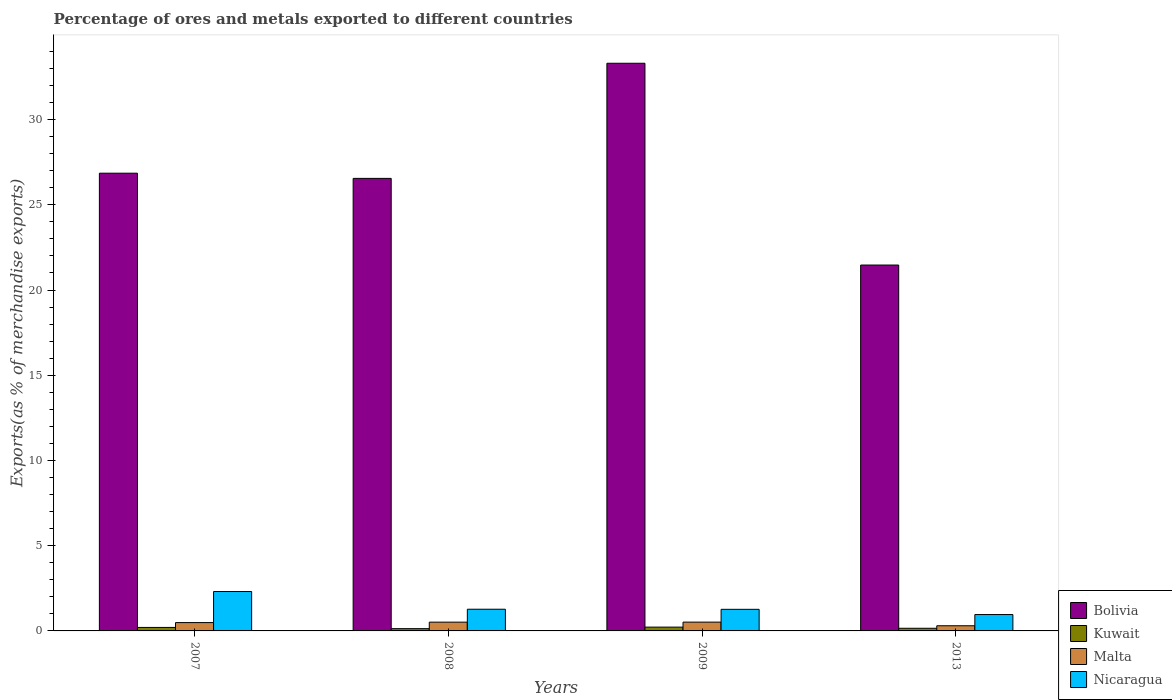How many groups of bars are there?
Your response must be concise. 4. How many bars are there on the 2nd tick from the left?
Provide a succinct answer. 4. How many bars are there on the 4th tick from the right?
Ensure brevity in your answer.  4. In how many cases, is the number of bars for a given year not equal to the number of legend labels?
Provide a short and direct response. 0. What is the percentage of exports to different countries in Kuwait in 2013?
Your answer should be very brief. 0.16. Across all years, what is the maximum percentage of exports to different countries in Bolivia?
Provide a succinct answer. 33.3. Across all years, what is the minimum percentage of exports to different countries in Kuwait?
Provide a short and direct response. 0.13. What is the total percentage of exports to different countries in Nicaragua in the graph?
Give a very brief answer. 5.81. What is the difference between the percentage of exports to different countries in Kuwait in 2007 and that in 2009?
Your answer should be compact. -0.02. What is the difference between the percentage of exports to different countries in Kuwait in 2007 and the percentage of exports to different countries in Malta in 2013?
Your answer should be very brief. -0.1. What is the average percentage of exports to different countries in Kuwait per year?
Offer a terse response. 0.18. In the year 2008, what is the difference between the percentage of exports to different countries in Kuwait and percentage of exports to different countries in Bolivia?
Provide a succinct answer. -26.42. What is the ratio of the percentage of exports to different countries in Bolivia in 2007 to that in 2009?
Offer a terse response. 0.81. Is the percentage of exports to different countries in Nicaragua in 2007 less than that in 2009?
Your answer should be very brief. No. What is the difference between the highest and the second highest percentage of exports to different countries in Malta?
Provide a succinct answer. 0. What is the difference between the highest and the lowest percentage of exports to different countries in Nicaragua?
Provide a short and direct response. 1.35. Is it the case that in every year, the sum of the percentage of exports to different countries in Kuwait and percentage of exports to different countries in Malta is greater than the sum of percentage of exports to different countries in Nicaragua and percentage of exports to different countries in Bolivia?
Provide a succinct answer. No. What does the 1st bar from the left in 2007 represents?
Your answer should be compact. Bolivia. Is it the case that in every year, the sum of the percentage of exports to different countries in Bolivia and percentage of exports to different countries in Nicaragua is greater than the percentage of exports to different countries in Malta?
Give a very brief answer. Yes. How many years are there in the graph?
Ensure brevity in your answer.  4. Are the values on the major ticks of Y-axis written in scientific E-notation?
Give a very brief answer. No. Does the graph contain any zero values?
Keep it short and to the point. No. Does the graph contain grids?
Provide a succinct answer. No. Where does the legend appear in the graph?
Make the answer very short. Bottom right. How many legend labels are there?
Keep it short and to the point. 4. What is the title of the graph?
Offer a terse response. Percentage of ores and metals exported to different countries. Does "Azerbaijan" appear as one of the legend labels in the graph?
Provide a short and direct response. No. What is the label or title of the Y-axis?
Offer a terse response. Exports(as % of merchandise exports). What is the Exports(as % of merchandise exports) of Bolivia in 2007?
Provide a succinct answer. 26.85. What is the Exports(as % of merchandise exports) in Kuwait in 2007?
Keep it short and to the point. 0.2. What is the Exports(as % of merchandise exports) of Malta in 2007?
Keep it short and to the point. 0.49. What is the Exports(as % of merchandise exports) in Nicaragua in 2007?
Provide a succinct answer. 2.31. What is the Exports(as % of merchandise exports) of Bolivia in 2008?
Ensure brevity in your answer.  26.55. What is the Exports(as % of merchandise exports) in Kuwait in 2008?
Provide a succinct answer. 0.13. What is the Exports(as % of merchandise exports) in Malta in 2008?
Offer a terse response. 0.51. What is the Exports(as % of merchandise exports) in Nicaragua in 2008?
Your response must be concise. 1.27. What is the Exports(as % of merchandise exports) in Bolivia in 2009?
Your response must be concise. 33.3. What is the Exports(as % of merchandise exports) of Kuwait in 2009?
Offer a terse response. 0.22. What is the Exports(as % of merchandise exports) of Malta in 2009?
Make the answer very short. 0.52. What is the Exports(as % of merchandise exports) of Nicaragua in 2009?
Your answer should be very brief. 1.27. What is the Exports(as % of merchandise exports) of Bolivia in 2013?
Offer a terse response. 21.46. What is the Exports(as % of merchandise exports) in Kuwait in 2013?
Your response must be concise. 0.16. What is the Exports(as % of merchandise exports) of Malta in 2013?
Offer a terse response. 0.3. What is the Exports(as % of merchandise exports) of Nicaragua in 2013?
Provide a succinct answer. 0.96. Across all years, what is the maximum Exports(as % of merchandise exports) in Bolivia?
Your answer should be compact. 33.3. Across all years, what is the maximum Exports(as % of merchandise exports) of Kuwait?
Offer a very short reply. 0.22. Across all years, what is the maximum Exports(as % of merchandise exports) of Malta?
Keep it short and to the point. 0.52. Across all years, what is the maximum Exports(as % of merchandise exports) in Nicaragua?
Your answer should be very brief. 2.31. Across all years, what is the minimum Exports(as % of merchandise exports) in Bolivia?
Provide a short and direct response. 21.46. Across all years, what is the minimum Exports(as % of merchandise exports) of Kuwait?
Offer a very short reply. 0.13. Across all years, what is the minimum Exports(as % of merchandise exports) in Malta?
Your response must be concise. 0.3. Across all years, what is the minimum Exports(as % of merchandise exports) of Nicaragua?
Your response must be concise. 0.96. What is the total Exports(as % of merchandise exports) in Bolivia in the graph?
Keep it short and to the point. 108.17. What is the total Exports(as % of merchandise exports) of Kuwait in the graph?
Make the answer very short. 0.72. What is the total Exports(as % of merchandise exports) of Malta in the graph?
Keep it short and to the point. 1.82. What is the total Exports(as % of merchandise exports) of Nicaragua in the graph?
Provide a succinct answer. 5.81. What is the difference between the Exports(as % of merchandise exports) of Bolivia in 2007 and that in 2008?
Keep it short and to the point. 0.3. What is the difference between the Exports(as % of merchandise exports) in Kuwait in 2007 and that in 2008?
Your answer should be very brief. 0.07. What is the difference between the Exports(as % of merchandise exports) in Malta in 2007 and that in 2008?
Your response must be concise. -0.03. What is the difference between the Exports(as % of merchandise exports) in Nicaragua in 2007 and that in 2008?
Your response must be concise. 1.04. What is the difference between the Exports(as % of merchandise exports) in Bolivia in 2007 and that in 2009?
Your answer should be very brief. -6.45. What is the difference between the Exports(as % of merchandise exports) in Kuwait in 2007 and that in 2009?
Your answer should be compact. -0.02. What is the difference between the Exports(as % of merchandise exports) in Malta in 2007 and that in 2009?
Keep it short and to the point. -0.03. What is the difference between the Exports(as % of merchandise exports) in Nicaragua in 2007 and that in 2009?
Make the answer very short. 1.04. What is the difference between the Exports(as % of merchandise exports) of Bolivia in 2007 and that in 2013?
Keep it short and to the point. 5.39. What is the difference between the Exports(as % of merchandise exports) in Kuwait in 2007 and that in 2013?
Your answer should be very brief. 0.05. What is the difference between the Exports(as % of merchandise exports) in Malta in 2007 and that in 2013?
Your response must be concise. 0.19. What is the difference between the Exports(as % of merchandise exports) in Nicaragua in 2007 and that in 2013?
Ensure brevity in your answer.  1.35. What is the difference between the Exports(as % of merchandise exports) in Bolivia in 2008 and that in 2009?
Ensure brevity in your answer.  -6.75. What is the difference between the Exports(as % of merchandise exports) in Kuwait in 2008 and that in 2009?
Your answer should be compact. -0.09. What is the difference between the Exports(as % of merchandise exports) in Malta in 2008 and that in 2009?
Provide a short and direct response. -0. What is the difference between the Exports(as % of merchandise exports) in Nicaragua in 2008 and that in 2009?
Give a very brief answer. 0.01. What is the difference between the Exports(as % of merchandise exports) of Bolivia in 2008 and that in 2013?
Ensure brevity in your answer.  5.08. What is the difference between the Exports(as % of merchandise exports) of Kuwait in 2008 and that in 2013?
Give a very brief answer. -0.02. What is the difference between the Exports(as % of merchandise exports) of Malta in 2008 and that in 2013?
Provide a short and direct response. 0.21. What is the difference between the Exports(as % of merchandise exports) of Nicaragua in 2008 and that in 2013?
Keep it short and to the point. 0.31. What is the difference between the Exports(as % of merchandise exports) in Bolivia in 2009 and that in 2013?
Offer a terse response. 11.84. What is the difference between the Exports(as % of merchandise exports) of Kuwait in 2009 and that in 2013?
Offer a very short reply. 0.07. What is the difference between the Exports(as % of merchandise exports) in Malta in 2009 and that in 2013?
Ensure brevity in your answer.  0.21. What is the difference between the Exports(as % of merchandise exports) of Nicaragua in 2009 and that in 2013?
Provide a succinct answer. 0.31. What is the difference between the Exports(as % of merchandise exports) of Bolivia in 2007 and the Exports(as % of merchandise exports) of Kuwait in 2008?
Your answer should be very brief. 26.72. What is the difference between the Exports(as % of merchandise exports) in Bolivia in 2007 and the Exports(as % of merchandise exports) in Malta in 2008?
Offer a terse response. 26.34. What is the difference between the Exports(as % of merchandise exports) of Bolivia in 2007 and the Exports(as % of merchandise exports) of Nicaragua in 2008?
Ensure brevity in your answer.  25.58. What is the difference between the Exports(as % of merchandise exports) of Kuwait in 2007 and the Exports(as % of merchandise exports) of Malta in 2008?
Provide a short and direct response. -0.31. What is the difference between the Exports(as % of merchandise exports) in Kuwait in 2007 and the Exports(as % of merchandise exports) in Nicaragua in 2008?
Provide a short and direct response. -1.07. What is the difference between the Exports(as % of merchandise exports) of Malta in 2007 and the Exports(as % of merchandise exports) of Nicaragua in 2008?
Provide a short and direct response. -0.78. What is the difference between the Exports(as % of merchandise exports) of Bolivia in 2007 and the Exports(as % of merchandise exports) of Kuwait in 2009?
Make the answer very short. 26.63. What is the difference between the Exports(as % of merchandise exports) of Bolivia in 2007 and the Exports(as % of merchandise exports) of Malta in 2009?
Offer a terse response. 26.34. What is the difference between the Exports(as % of merchandise exports) in Bolivia in 2007 and the Exports(as % of merchandise exports) in Nicaragua in 2009?
Keep it short and to the point. 25.59. What is the difference between the Exports(as % of merchandise exports) in Kuwait in 2007 and the Exports(as % of merchandise exports) in Malta in 2009?
Give a very brief answer. -0.31. What is the difference between the Exports(as % of merchandise exports) of Kuwait in 2007 and the Exports(as % of merchandise exports) of Nicaragua in 2009?
Give a very brief answer. -1.06. What is the difference between the Exports(as % of merchandise exports) of Malta in 2007 and the Exports(as % of merchandise exports) of Nicaragua in 2009?
Your answer should be compact. -0.78. What is the difference between the Exports(as % of merchandise exports) in Bolivia in 2007 and the Exports(as % of merchandise exports) in Kuwait in 2013?
Provide a short and direct response. 26.7. What is the difference between the Exports(as % of merchandise exports) in Bolivia in 2007 and the Exports(as % of merchandise exports) in Malta in 2013?
Make the answer very short. 26.55. What is the difference between the Exports(as % of merchandise exports) in Bolivia in 2007 and the Exports(as % of merchandise exports) in Nicaragua in 2013?
Provide a succinct answer. 25.89. What is the difference between the Exports(as % of merchandise exports) in Kuwait in 2007 and the Exports(as % of merchandise exports) in Malta in 2013?
Keep it short and to the point. -0.1. What is the difference between the Exports(as % of merchandise exports) of Kuwait in 2007 and the Exports(as % of merchandise exports) of Nicaragua in 2013?
Keep it short and to the point. -0.76. What is the difference between the Exports(as % of merchandise exports) of Malta in 2007 and the Exports(as % of merchandise exports) of Nicaragua in 2013?
Keep it short and to the point. -0.47. What is the difference between the Exports(as % of merchandise exports) in Bolivia in 2008 and the Exports(as % of merchandise exports) in Kuwait in 2009?
Ensure brevity in your answer.  26.33. What is the difference between the Exports(as % of merchandise exports) in Bolivia in 2008 and the Exports(as % of merchandise exports) in Malta in 2009?
Provide a short and direct response. 26.03. What is the difference between the Exports(as % of merchandise exports) in Bolivia in 2008 and the Exports(as % of merchandise exports) in Nicaragua in 2009?
Make the answer very short. 25.28. What is the difference between the Exports(as % of merchandise exports) in Kuwait in 2008 and the Exports(as % of merchandise exports) in Malta in 2009?
Your answer should be compact. -0.38. What is the difference between the Exports(as % of merchandise exports) in Kuwait in 2008 and the Exports(as % of merchandise exports) in Nicaragua in 2009?
Make the answer very short. -1.13. What is the difference between the Exports(as % of merchandise exports) of Malta in 2008 and the Exports(as % of merchandise exports) of Nicaragua in 2009?
Give a very brief answer. -0.75. What is the difference between the Exports(as % of merchandise exports) in Bolivia in 2008 and the Exports(as % of merchandise exports) in Kuwait in 2013?
Your response must be concise. 26.39. What is the difference between the Exports(as % of merchandise exports) in Bolivia in 2008 and the Exports(as % of merchandise exports) in Malta in 2013?
Your answer should be very brief. 26.25. What is the difference between the Exports(as % of merchandise exports) of Bolivia in 2008 and the Exports(as % of merchandise exports) of Nicaragua in 2013?
Offer a terse response. 25.59. What is the difference between the Exports(as % of merchandise exports) in Kuwait in 2008 and the Exports(as % of merchandise exports) in Malta in 2013?
Keep it short and to the point. -0.17. What is the difference between the Exports(as % of merchandise exports) of Kuwait in 2008 and the Exports(as % of merchandise exports) of Nicaragua in 2013?
Keep it short and to the point. -0.83. What is the difference between the Exports(as % of merchandise exports) in Malta in 2008 and the Exports(as % of merchandise exports) in Nicaragua in 2013?
Offer a terse response. -0.45. What is the difference between the Exports(as % of merchandise exports) in Bolivia in 2009 and the Exports(as % of merchandise exports) in Kuwait in 2013?
Give a very brief answer. 33.15. What is the difference between the Exports(as % of merchandise exports) in Bolivia in 2009 and the Exports(as % of merchandise exports) in Malta in 2013?
Provide a short and direct response. 33. What is the difference between the Exports(as % of merchandise exports) of Bolivia in 2009 and the Exports(as % of merchandise exports) of Nicaragua in 2013?
Provide a short and direct response. 32.34. What is the difference between the Exports(as % of merchandise exports) in Kuwait in 2009 and the Exports(as % of merchandise exports) in Malta in 2013?
Your answer should be very brief. -0.08. What is the difference between the Exports(as % of merchandise exports) of Kuwait in 2009 and the Exports(as % of merchandise exports) of Nicaragua in 2013?
Make the answer very short. -0.74. What is the difference between the Exports(as % of merchandise exports) of Malta in 2009 and the Exports(as % of merchandise exports) of Nicaragua in 2013?
Offer a very short reply. -0.44. What is the average Exports(as % of merchandise exports) in Bolivia per year?
Give a very brief answer. 27.04. What is the average Exports(as % of merchandise exports) of Kuwait per year?
Your response must be concise. 0.18. What is the average Exports(as % of merchandise exports) of Malta per year?
Offer a terse response. 0.46. What is the average Exports(as % of merchandise exports) of Nicaragua per year?
Your response must be concise. 1.45. In the year 2007, what is the difference between the Exports(as % of merchandise exports) of Bolivia and Exports(as % of merchandise exports) of Kuwait?
Offer a terse response. 26.65. In the year 2007, what is the difference between the Exports(as % of merchandise exports) of Bolivia and Exports(as % of merchandise exports) of Malta?
Keep it short and to the point. 26.37. In the year 2007, what is the difference between the Exports(as % of merchandise exports) of Bolivia and Exports(as % of merchandise exports) of Nicaragua?
Your answer should be very brief. 24.54. In the year 2007, what is the difference between the Exports(as % of merchandise exports) in Kuwait and Exports(as % of merchandise exports) in Malta?
Your answer should be very brief. -0.28. In the year 2007, what is the difference between the Exports(as % of merchandise exports) in Kuwait and Exports(as % of merchandise exports) in Nicaragua?
Your answer should be compact. -2.11. In the year 2007, what is the difference between the Exports(as % of merchandise exports) of Malta and Exports(as % of merchandise exports) of Nicaragua?
Make the answer very short. -1.82. In the year 2008, what is the difference between the Exports(as % of merchandise exports) in Bolivia and Exports(as % of merchandise exports) in Kuwait?
Your answer should be compact. 26.42. In the year 2008, what is the difference between the Exports(as % of merchandise exports) in Bolivia and Exports(as % of merchandise exports) in Malta?
Ensure brevity in your answer.  26.04. In the year 2008, what is the difference between the Exports(as % of merchandise exports) in Bolivia and Exports(as % of merchandise exports) in Nicaragua?
Give a very brief answer. 25.28. In the year 2008, what is the difference between the Exports(as % of merchandise exports) in Kuwait and Exports(as % of merchandise exports) in Malta?
Your answer should be compact. -0.38. In the year 2008, what is the difference between the Exports(as % of merchandise exports) in Kuwait and Exports(as % of merchandise exports) in Nicaragua?
Offer a very short reply. -1.14. In the year 2008, what is the difference between the Exports(as % of merchandise exports) of Malta and Exports(as % of merchandise exports) of Nicaragua?
Offer a terse response. -0.76. In the year 2009, what is the difference between the Exports(as % of merchandise exports) of Bolivia and Exports(as % of merchandise exports) of Kuwait?
Make the answer very short. 33.08. In the year 2009, what is the difference between the Exports(as % of merchandise exports) in Bolivia and Exports(as % of merchandise exports) in Malta?
Provide a succinct answer. 32.79. In the year 2009, what is the difference between the Exports(as % of merchandise exports) of Bolivia and Exports(as % of merchandise exports) of Nicaragua?
Your response must be concise. 32.04. In the year 2009, what is the difference between the Exports(as % of merchandise exports) of Kuwait and Exports(as % of merchandise exports) of Malta?
Make the answer very short. -0.29. In the year 2009, what is the difference between the Exports(as % of merchandise exports) in Kuwait and Exports(as % of merchandise exports) in Nicaragua?
Ensure brevity in your answer.  -1.04. In the year 2009, what is the difference between the Exports(as % of merchandise exports) in Malta and Exports(as % of merchandise exports) in Nicaragua?
Offer a terse response. -0.75. In the year 2013, what is the difference between the Exports(as % of merchandise exports) in Bolivia and Exports(as % of merchandise exports) in Kuwait?
Ensure brevity in your answer.  21.31. In the year 2013, what is the difference between the Exports(as % of merchandise exports) of Bolivia and Exports(as % of merchandise exports) of Malta?
Offer a terse response. 21.16. In the year 2013, what is the difference between the Exports(as % of merchandise exports) in Bolivia and Exports(as % of merchandise exports) in Nicaragua?
Ensure brevity in your answer.  20.5. In the year 2013, what is the difference between the Exports(as % of merchandise exports) of Kuwait and Exports(as % of merchandise exports) of Malta?
Your answer should be very brief. -0.15. In the year 2013, what is the difference between the Exports(as % of merchandise exports) in Kuwait and Exports(as % of merchandise exports) in Nicaragua?
Offer a very short reply. -0.81. In the year 2013, what is the difference between the Exports(as % of merchandise exports) of Malta and Exports(as % of merchandise exports) of Nicaragua?
Your answer should be compact. -0.66. What is the ratio of the Exports(as % of merchandise exports) in Bolivia in 2007 to that in 2008?
Offer a very short reply. 1.01. What is the ratio of the Exports(as % of merchandise exports) of Kuwait in 2007 to that in 2008?
Your answer should be compact. 1.54. What is the ratio of the Exports(as % of merchandise exports) of Malta in 2007 to that in 2008?
Your answer should be very brief. 0.95. What is the ratio of the Exports(as % of merchandise exports) of Nicaragua in 2007 to that in 2008?
Provide a succinct answer. 1.82. What is the ratio of the Exports(as % of merchandise exports) of Bolivia in 2007 to that in 2009?
Your answer should be very brief. 0.81. What is the ratio of the Exports(as % of merchandise exports) of Kuwait in 2007 to that in 2009?
Keep it short and to the point. 0.92. What is the ratio of the Exports(as % of merchandise exports) of Malta in 2007 to that in 2009?
Your answer should be very brief. 0.95. What is the ratio of the Exports(as % of merchandise exports) in Nicaragua in 2007 to that in 2009?
Give a very brief answer. 1.82. What is the ratio of the Exports(as % of merchandise exports) in Bolivia in 2007 to that in 2013?
Your answer should be compact. 1.25. What is the ratio of the Exports(as % of merchandise exports) in Kuwait in 2007 to that in 2013?
Offer a terse response. 1.32. What is the ratio of the Exports(as % of merchandise exports) of Malta in 2007 to that in 2013?
Give a very brief answer. 1.61. What is the ratio of the Exports(as % of merchandise exports) of Nicaragua in 2007 to that in 2013?
Your answer should be compact. 2.41. What is the ratio of the Exports(as % of merchandise exports) in Bolivia in 2008 to that in 2009?
Offer a very short reply. 0.8. What is the ratio of the Exports(as % of merchandise exports) in Kuwait in 2008 to that in 2009?
Keep it short and to the point. 0.6. What is the ratio of the Exports(as % of merchandise exports) in Nicaragua in 2008 to that in 2009?
Give a very brief answer. 1. What is the ratio of the Exports(as % of merchandise exports) in Bolivia in 2008 to that in 2013?
Offer a terse response. 1.24. What is the ratio of the Exports(as % of merchandise exports) of Kuwait in 2008 to that in 2013?
Offer a very short reply. 0.86. What is the ratio of the Exports(as % of merchandise exports) in Malta in 2008 to that in 2013?
Offer a terse response. 1.7. What is the ratio of the Exports(as % of merchandise exports) of Nicaragua in 2008 to that in 2013?
Provide a succinct answer. 1.33. What is the ratio of the Exports(as % of merchandise exports) in Bolivia in 2009 to that in 2013?
Keep it short and to the point. 1.55. What is the ratio of the Exports(as % of merchandise exports) in Kuwait in 2009 to that in 2013?
Provide a succinct answer. 1.44. What is the ratio of the Exports(as % of merchandise exports) in Malta in 2009 to that in 2013?
Ensure brevity in your answer.  1.71. What is the ratio of the Exports(as % of merchandise exports) of Nicaragua in 2009 to that in 2013?
Your answer should be very brief. 1.32. What is the difference between the highest and the second highest Exports(as % of merchandise exports) in Bolivia?
Ensure brevity in your answer.  6.45. What is the difference between the highest and the second highest Exports(as % of merchandise exports) of Kuwait?
Ensure brevity in your answer.  0.02. What is the difference between the highest and the second highest Exports(as % of merchandise exports) of Malta?
Your answer should be very brief. 0. What is the difference between the highest and the second highest Exports(as % of merchandise exports) of Nicaragua?
Offer a very short reply. 1.04. What is the difference between the highest and the lowest Exports(as % of merchandise exports) in Bolivia?
Your answer should be compact. 11.84. What is the difference between the highest and the lowest Exports(as % of merchandise exports) in Kuwait?
Make the answer very short. 0.09. What is the difference between the highest and the lowest Exports(as % of merchandise exports) in Malta?
Keep it short and to the point. 0.21. What is the difference between the highest and the lowest Exports(as % of merchandise exports) in Nicaragua?
Offer a terse response. 1.35. 